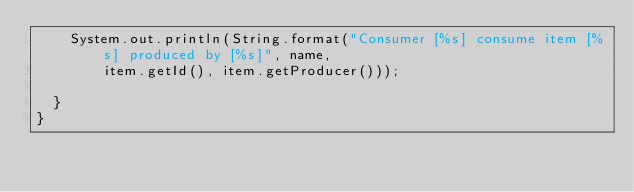<code> <loc_0><loc_0><loc_500><loc_500><_Java_>    System.out.println(String.format("Consumer [%s] consume item [%s] produced by [%s]", name,
        item.getId(), item.getProducer()));

  }
}
</code> 